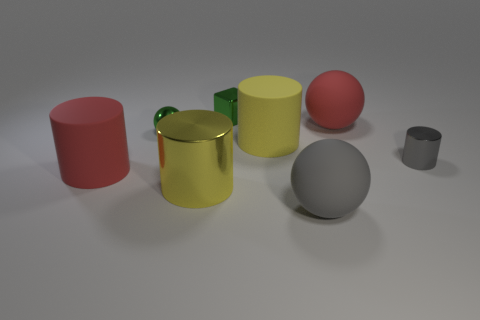If the objects had to represent a family, what roles could each of them play? If we humanize the objects, we could imagine the two larger cylinders as the parents due to their size and presence, the two spheres as children with their playful and dynamic shapes, and the tiny cylinder as a pet or younger sibling due to its smaller size and different texture, which could represent youth or a different kind of energy within the family dynamic. 